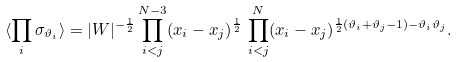<formula> <loc_0><loc_0><loc_500><loc_500>\langle \prod _ { i } \sigma _ { \vartheta _ { i } } \rangle = | W | ^ { - \frac { 1 } { 2 } } \prod _ { i < j } ^ { N - 3 } ( x _ { i } - x _ { j } ) ^ { \frac { 1 } { 2 } } \, \prod _ { i < j } ^ { N } ( x _ { i } - x _ { j } ) ^ { \frac { 1 } { 2 } ( \vartheta _ { i } + \vartheta _ { j } - 1 ) - \vartheta _ { i } \vartheta _ { j } } .</formula> 